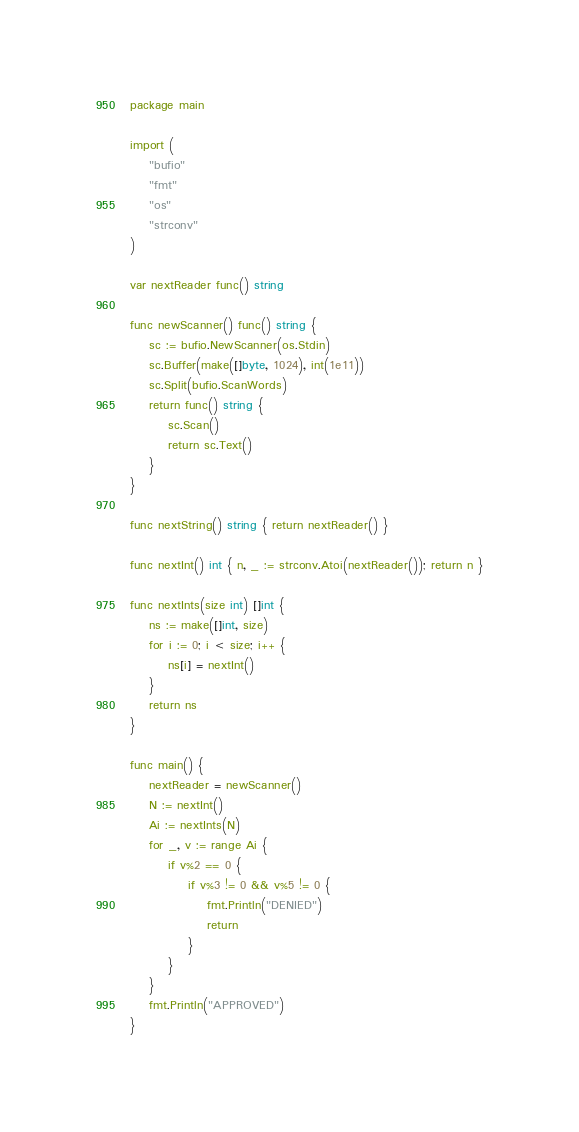<code> <loc_0><loc_0><loc_500><loc_500><_Go_>package main

import (
	"bufio"
	"fmt"
	"os"
	"strconv"
)

var nextReader func() string

func newScanner() func() string {
	sc := bufio.NewScanner(os.Stdin)
	sc.Buffer(make([]byte, 1024), int(1e11))
	sc.Split(bufio.ScanWords)
	return func() string {
		sc.Scan()
		return sc.Text()
	}
}

func nextString() string { return nextReader() }

func nextInt() int { n, _ := strconv.Atoi(nextReader()); return n }

func nextInts(size int) []int {
	ns := make([]int, size)
	for i := 0; i < size; i++ {
		ns[i] = nextInt()
	}
	return ns
}

func main() {
	nextReader = newScanner()
	N := nextInt()
	Ai := nextInts(N)
	for _, v := range Ai {
		if v%2 == 0 {
			if v%3 != 0 && v%5 != 0 {
				fmt.Println("DENIED")
				return
			}
		}
	}
	fmt.Println("APPROVED")
}
</code> 